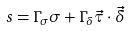<formula> <loc_0><loc_0><loc_500><loc_500>s = \Gamma _ { \sigma } \sigma + \Gamma _ { \delta } \vec { \tau } \cdot \vec { \delta }</formula> 